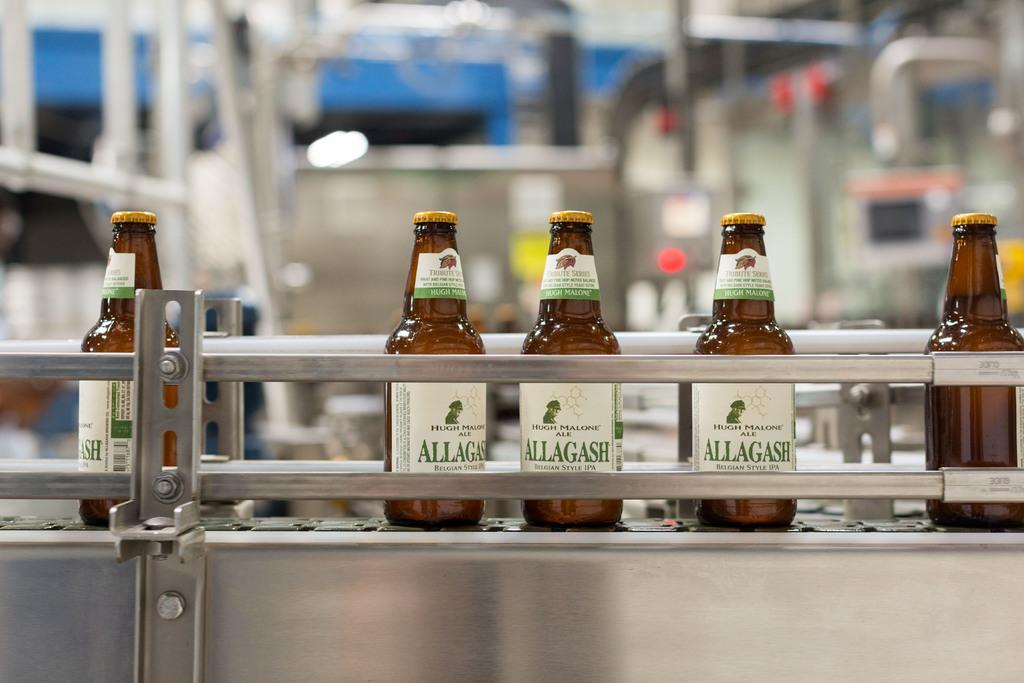<image>
Present a compact description of the photo's key features. Bottles of Hugh Malone Ale move down a conveyor belt at the bottling plant. 